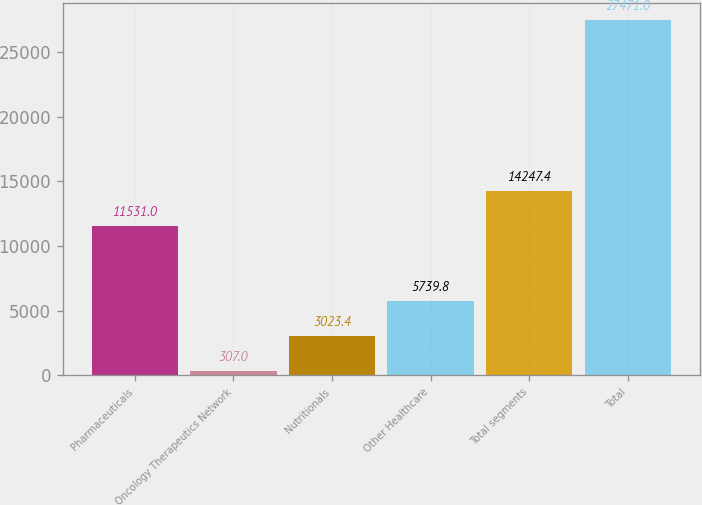<chart> <loc_0><loc_0><loc_500><loc_500><bar_chart><fcel>Pharmaceuticals<fcel>Oncology Therapeutics Network<fcel>Nutritionals<fcel>Other Healthcare<fcel>Total segments<fcel>Total<nl><fcel>11531<fcel>307<fcel>3023.4<fcel>5739.8<fcel>14247.4<fcel>27471<nl></chart> 